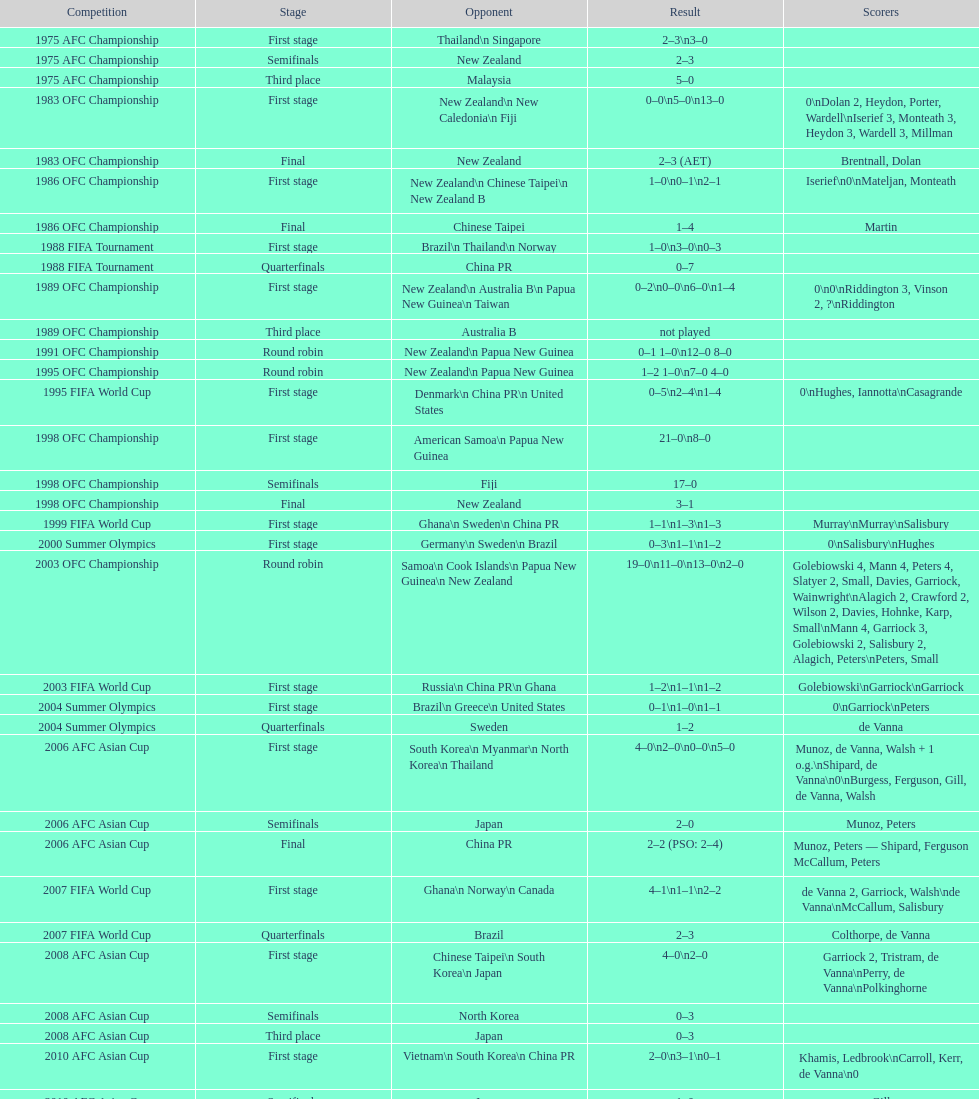During the 2012 summer olympics afc qualification's final round, how many points were accumulated in total? 12. 